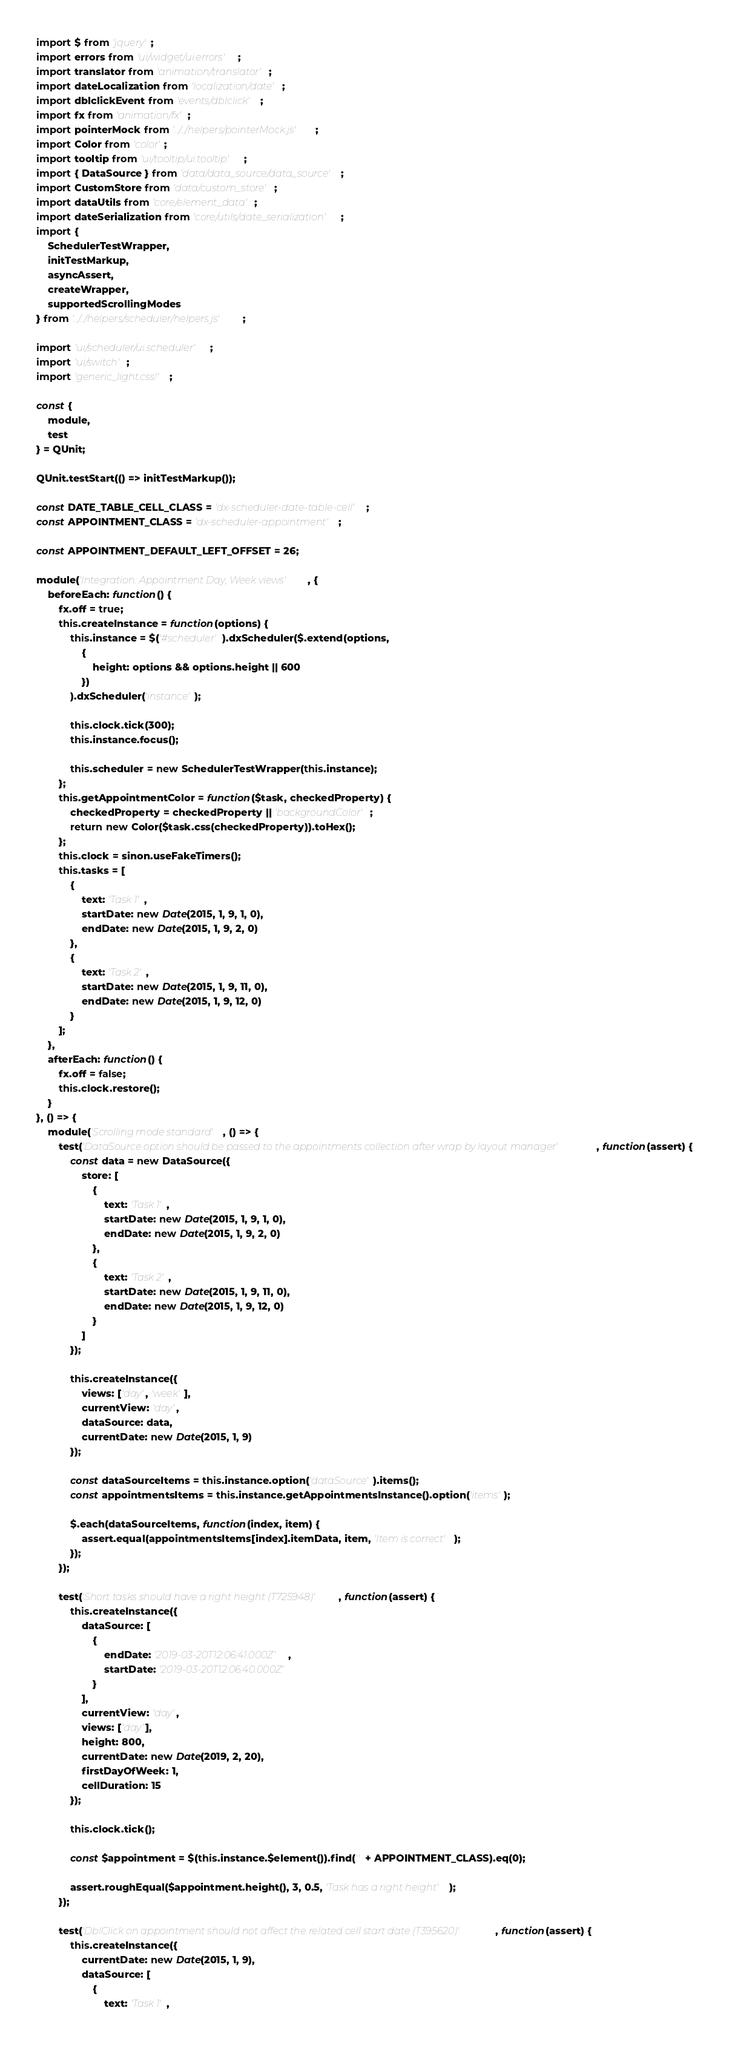Convert code to text. <code><loc_0><loc_0><loc_500><loc_500><_JavaScript_>import $ from 'jquery';
import errors from 'ui/widget/ui.errors';
import translator from 'animation/translator';
import dateLocalization from 'localization/date';
import dblclickEvent from 'events/dblclick';
import fx from 'animation/fx';
import pointerMock from '../../helpers/pointerMock.js';
import Color from 'color';
import tooltip from 'ui/tooltip/ui.tooltip';
import { DataSource } from 'data/data_source/data_source';
import CustomStore from 'data/custom_store';
import dataUtils from 'core/element_data';
import dateSerialization from 'core/utils/date_serialization';
import {
    SchedulerTestWrapper,
    initTestMarkup,
    asyncAssert,
    createWrapper,
    supportedScrollingModes
} from '../../helpers/scheduler/helpers.js';

import 'ui/scheduler/ui.scheduler';
import 'ui/switch';
import 'generic_light.css!';

const {
    module,
    test
} = QUnit;

QUnit.testStart(() => initTestMarkup());

const DATE_TABLE_CELL_CLASS = 'dx-scheduler-date-table-cell';
const APPOINTMENT_CLASS = 'dx-scheduler-appointment';

const APPOINTMENT_DEFAULT_LEFT_OFFSET = 26;

module('Integration: Appointment Day, Week views', {
    beforeEach: function() {
        fx.off = true;
        this.createInstance = function(options) {
            this.instance = $('#scheduler').dxScheduler($.extend(options,
                {
                    height: options && options.height || 600
                })
            ).dxScheduler('instance');

            this.clock.tick(300);
            this.instance.focus();

            this.scheduler = new SchedulerTestWrapper(this.instance);
        };
        this.getAppointmentColor = function($task, checkedProperty) {
            checkedProperty = checkedProperty || 'backgroundColor';
            return new Color($task.css(checkedProperty)).toHex();
        };
        this.clock = sinon.useFakeTimers();
        this.tasks = [
            {
                text: 'Task 1',
                startDate: new Date(2015, 1, 9, 1, 0),
                endDate: new Date(2015, 1, 9, 2, 0)
            },
            {
                text: 'Task 2',
                startDate: new Date(2015, 1, 9, 11, 0),
                endDate: new Date(2015, 1, 9, 12, 0)
            }
        ];
    },
    afterEach: function() {
        fx.off = false;
        this.clock.restore();
    }
}, () => {
    module('Scrolling mode standard', () => {
        test('DataSource option should be passed to the appointments collection after wrap by layout manager', function(assert) {
            const data = new DataSource({
                store: [
                    {
                        text: 'Task 1',
                        startDate: new Date(2015, 1, 9, 1, 0),
                        endDate: new Date(2015, 1, 9, 2, 0)
                    },
                    {
                        text: 'Task 2',
                        startDate: new Date(2015, 1, 9, 11, 0),
                        endDate: new Date(2015, 1, 9, 12, 0)
                    }
                ]
            });

            this.createInstance({
                views: ['day', 'week'],
                currentView: 'day',
                dataSource: data,
                currentDate: new Date(2015, 1, 9)
            });

            const dataSourceItems = this.instance.option('dataSource').items();
            const appointmentsItems = this.instance.getAppointmentsInstance().option('items');

            $.each(dataSourceItems, function(index, item) {
                assert.equal(appointmentsItems[index].itemData, item, 'Item is correct');
            });
        });

        test('Short tasks should have a right height (T725948)', function(assert) {
            this.createInstance({
                dataSource: [
                    {
                        endDate: '2019-03-20T12:06:41.000Z',
                        startDate: '2019-03-20T12:06:40.000Z'
                    }
                ],
                currentView: 'day',
                views: ['day'],
                height: 800,
                currentDate: new Date(2019, 2, 20),
                firstDayOfWeek: 1,
                cellDuration: 15
            });

            this.clock.tick();

            const $appointment = $(this.instance.$element()).find('.' + APPOINTMENT_CLASS).eq(0);

            assert.roughEqual($appointment.height(), 3, 0.5, 'Task has a right height');
        });

        test('DblClick on appointment should not affect the related cell start date (T395620)', function(assert) {
            this.createInstance({
                currentDate: new Date(2015, 1, 9),
                dataSource: [
                    {
                        text: 'Task 1',</code> 